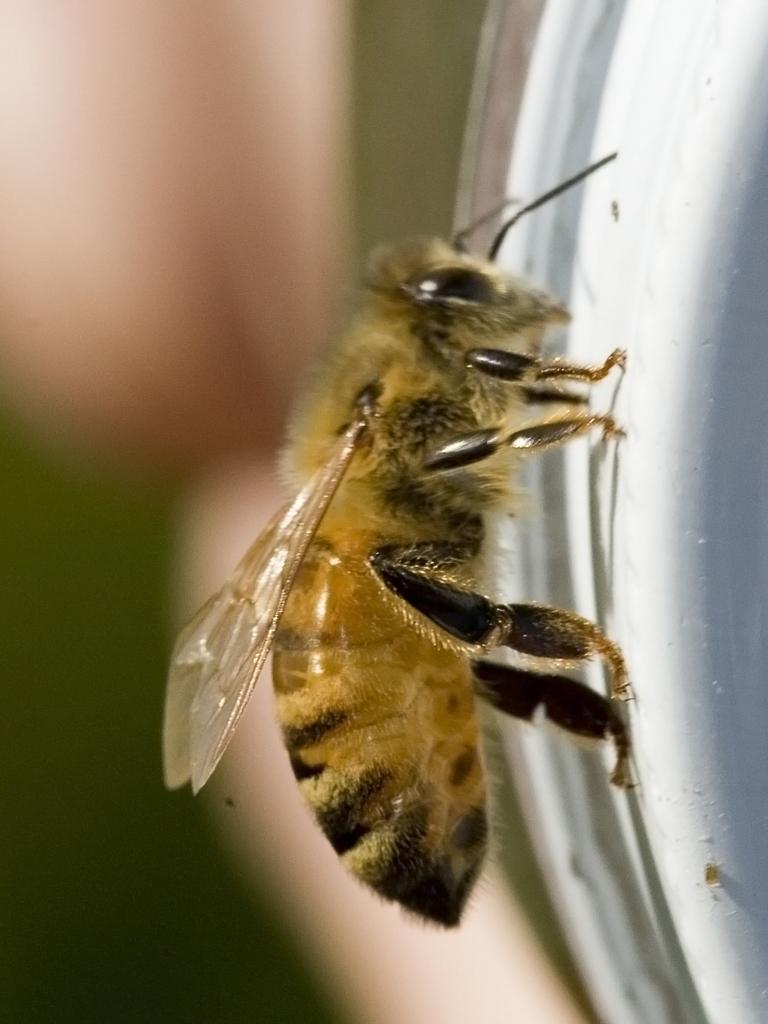Could you give a brief overview of what you see in this image? In the image there is some insect and the background of the insect is blur. 